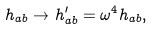Convert formula to latex. <formula><loc_0><loc_0><loc_500><loc_500>h _ { a b } \rightarrow h ^ { \prime } _ { a b } = \omega ^ { 4 } h _ { a b } ,</formula> 